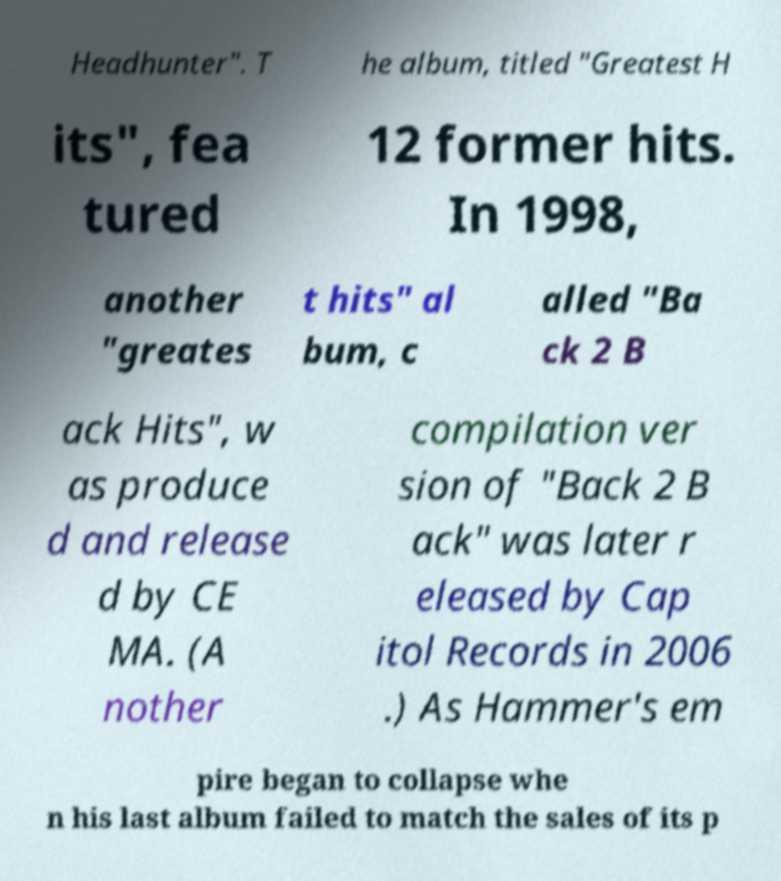What messages or text are displayed in this image? I need them in a readable, typed format. Headhunter". T he album, titled "Greatest H its", fea tured 12 former hits. In 1998, another "greates t hits" al bum, c alled "Ba ck 2 B ack Hits", w as produce d and release d by CE MA. (A nother compilation ver sion of "Back 2 B ack" was later r eleased by Cap itol Records in 2006 .) As Hammer's em pire began to collapse whe n his last album failed to match the sales of its p 